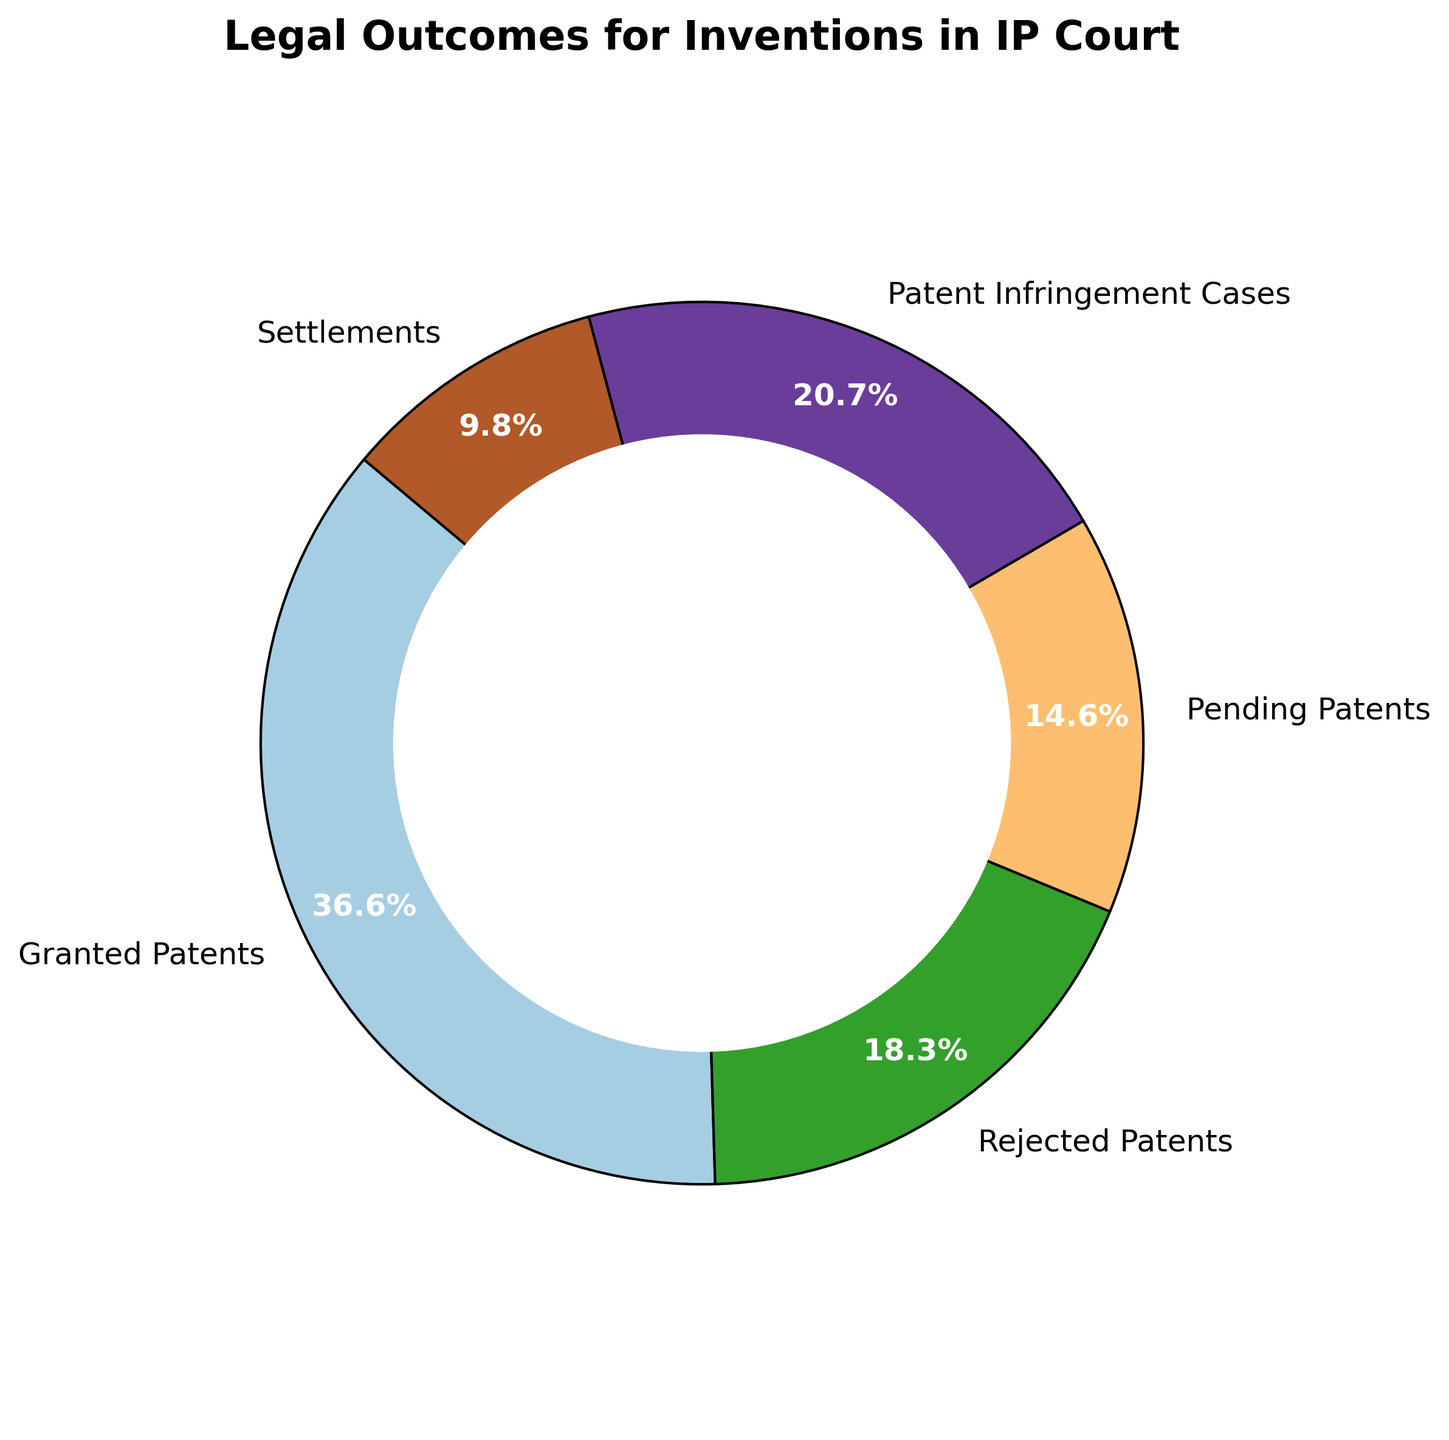What's the category with the largest count? Observe the pie chart and identify the category with the largest segment. "Granted Patents" has the largest portion at 150.
Answer: Granted Patents What's the combined count of "Settlements" and "Pending Patents"? Look at the counts for "Settlements" (40) and "Pending Patents" (60). Add them up: 40 + 60 = 100.
Answer: 100 Is the count of "Patent Infringement Cases" greater than "Rejected Patents"? Compare the counts of "Patent Infringement Cases" (85) and "Rejected Patents" (75). 85 is greater than 75.
Answer: Yes How many cases are not granted (excluding Granted Patents)? Sum up the counts of all categories except "Granted Patents": 75 (Rejected) + 60 (Pending) + 85 (Infringement) + 40 (Settlements) = 260.
Answer: 260 What percentage of the total cases are "Pending Patents"? First, calculate the total number of cases: 150 + 75 + 60 + 85 + 40 = 410. Then, find the percentage of "Pending Patents": (60/410) * 100 ≈ 14.6%.
Answer: 14.6% Which category has the smallest count, and what is the count? Identify the smallest segment in the pie chart. "Settlements" has the smallest count of 40.
Answer: Settlements, 40 How does the count of "Patent Infringement Cases" compare to the count of "Granted Patents"? Look at both counts: "Patent Infringement Cases" (85) and "Granted Patents" (150). 85 is less than 150.
Answer: Less What's the total count of "Rejected Patents" and "Patent Infringement Cases" compared to “Granted Patents”? Sum "Rejected Patents" (75) and "Patent Infringement Cases" (85): 75 + 85 = 160. Compare this to 150 ("Granted Patents"). 160 is greater than 150.
Answer: 160, Greater If you had to choose between "Settlements" and "Pending Patents" based on their counts, which would be more and by how much? Compare the counts: "Pending Patents" (60) and "Settlements" (40). Subtract the smaller from the larger: 60 - 40 = 20.
Answer: Pending Patents, 20 